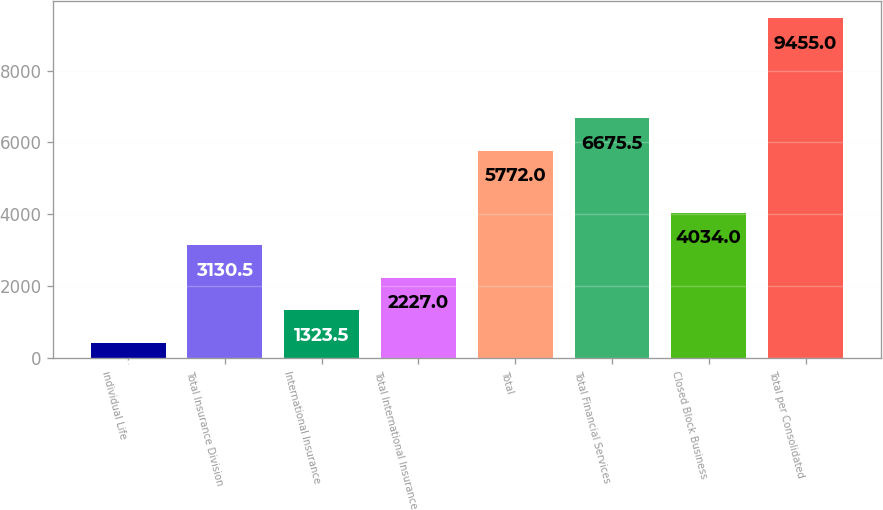Convert chart. <chart><loc_0><loc_0><loc_500><loc_500><bar_chart><fcel>Individual Life<fcel>Total Insurance Division<fcel>International Insurance<fcel>Total International Insurance<fcel>Total<fcel>Total Financial Services<fcel>Closed Block Business<fcel>Total per Consolidated<nl><fcel>420<fcel>3130.5<fcel>1323.5<fcel>2227<fcel>5772<fcel>6675.5<fcel>4034<fcel>9455<nl></chart> 